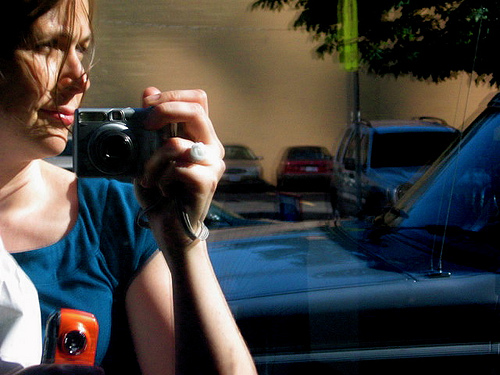What can be done using the orange thing?
A. eat food
B. take pictures
C. fly around
D. lock house
Answer with the option's letter from the given choices directly. B 